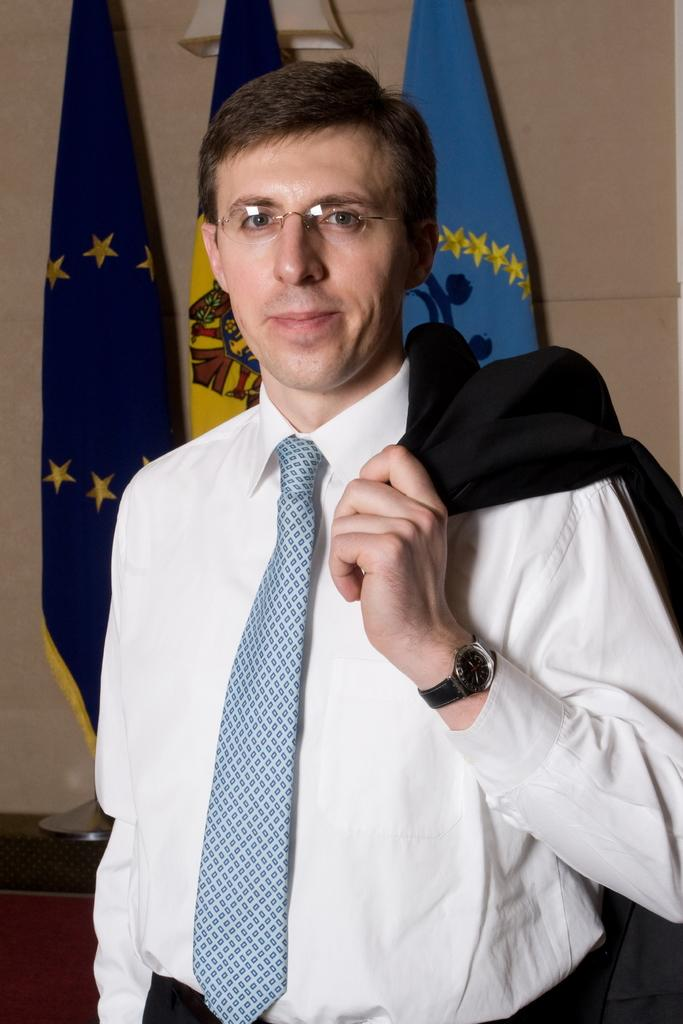Who or what is present in the image? There is a person in the image. What is the person wearing? The person is wearing goggles. What can be seen on the table in the image? There are flags on a table in the image. What is attached to the wall in the image? There is an object attached to the wall in the image. What type of stamp is being discussed by the committee in the image? There is no committee or stamp present in the image. What attraction is the person visiting in the image? There is no attraction mentioned or visible in the image. 